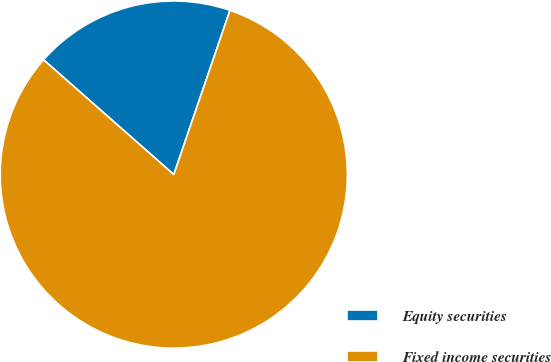Convert chart. <chart><loc_0><loc_0><loc_500><loc_500><pie_chart><fcel>Equity securities<fcel>Fixed income securities<nl><fcel>18.75%<fcel>81.25%<nl></chart> 